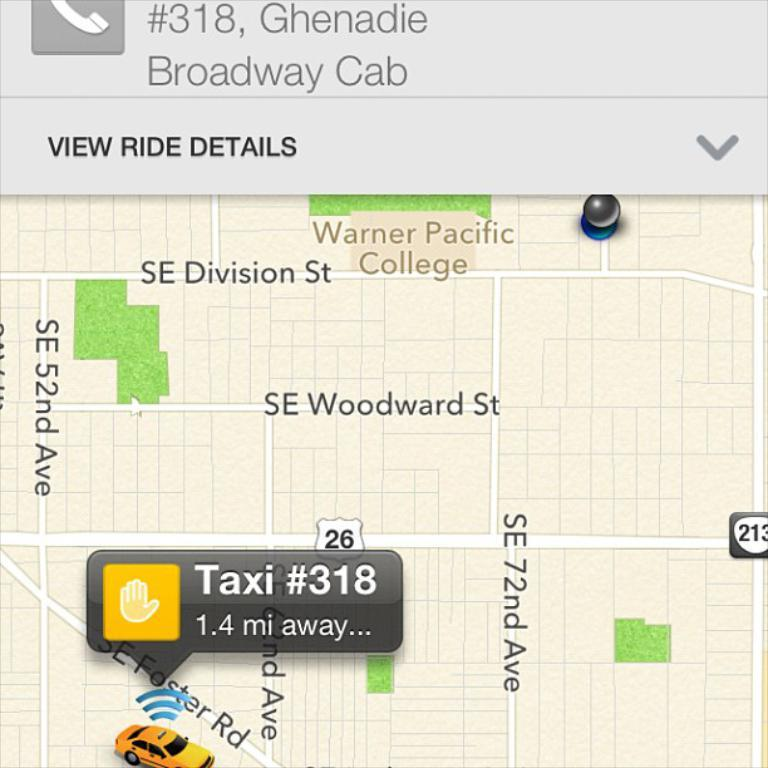<image>
Offer a succinct explanation of the picture presented. A map has a marker that says Taxi #318 and an option to View Ride Details above it. 